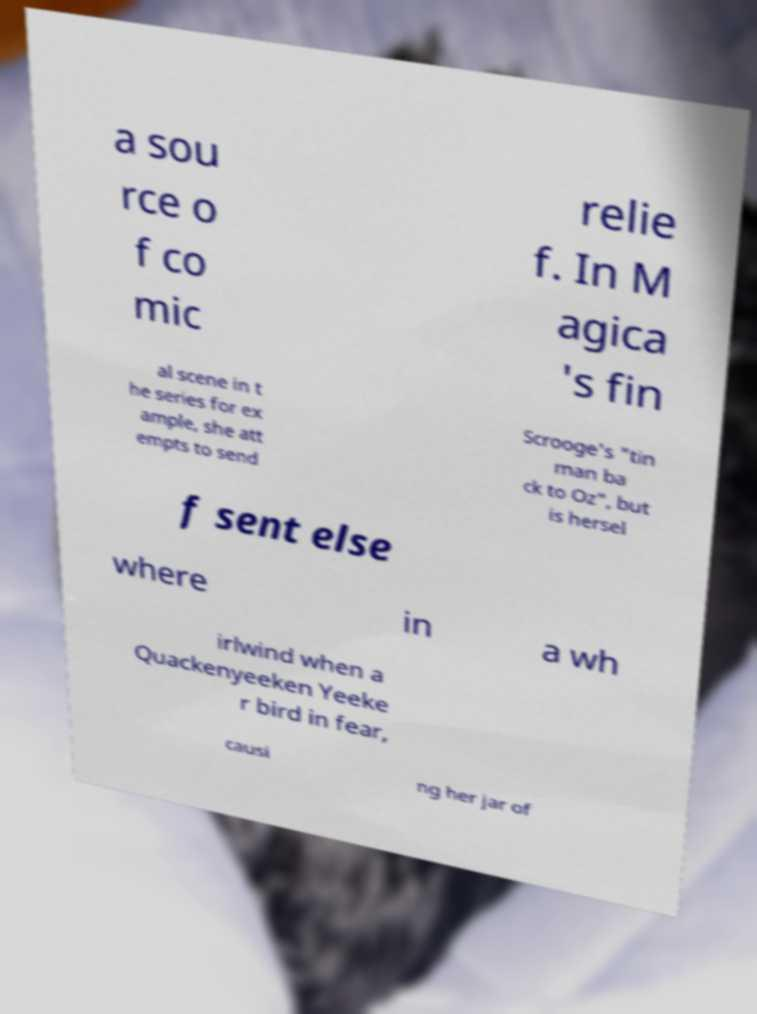Can you accurately transcribe the text from the provided image for me? a sou rce o f co mic relie f. In M agica 's fin al scene in t he series for ex ample, she att empts to send Scrooge's "tin man ba ck to Oz", but is hersel f sent else where in a wh irlwind when a Quackenyeeken Yeeke r bird in fear, causi ng her jar of 